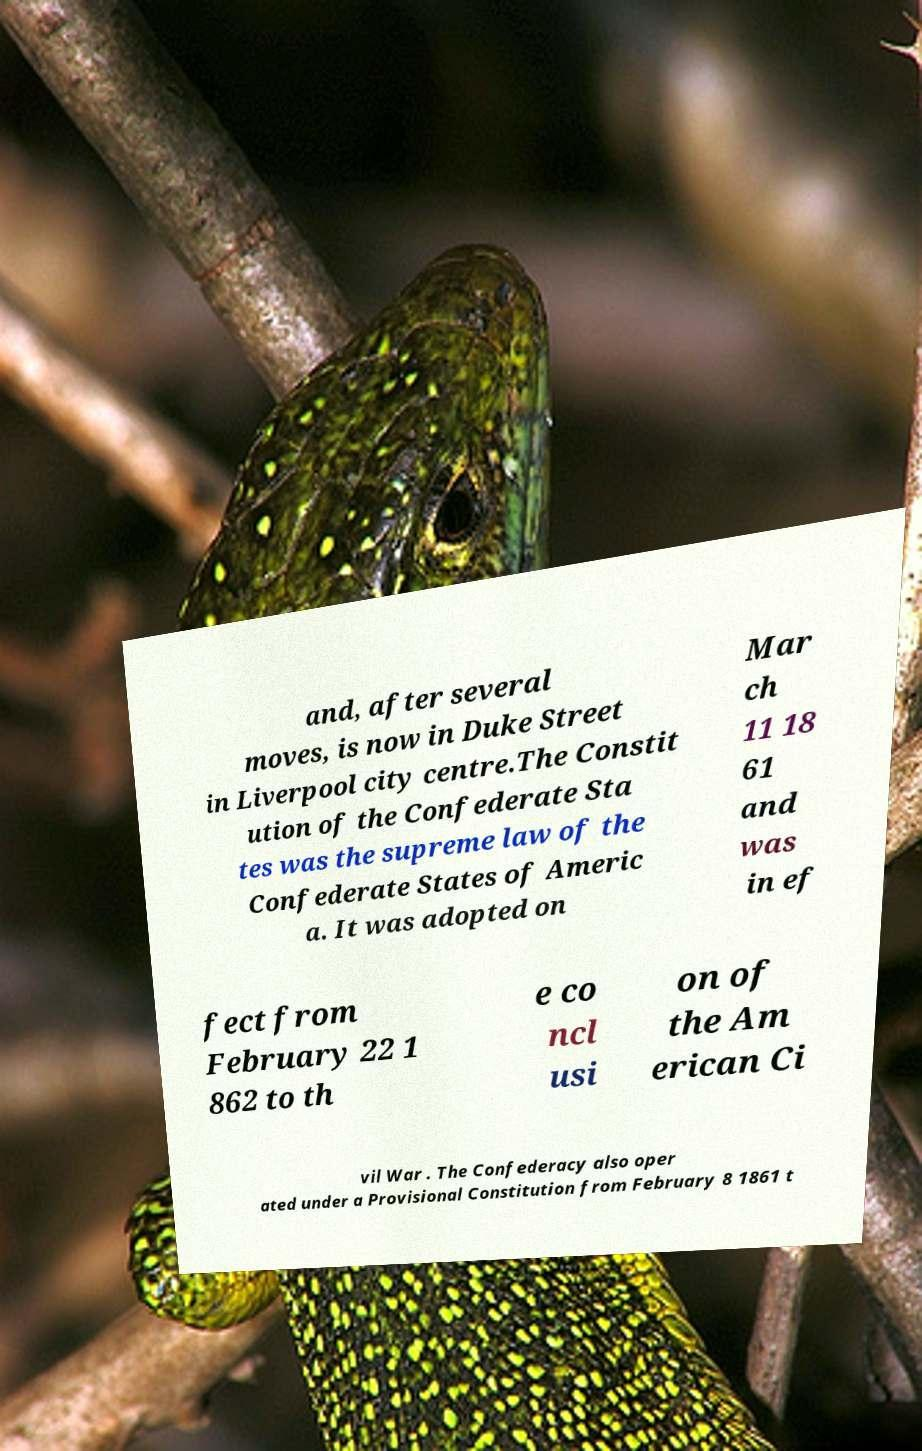For documentation purposes, I need the text within this image transcribed. Could you provide that? and, after several moves, is now in Duke Street in Liverpool city centre.The Constit ution of the Confederate Sta tes was the supreme law of the Confederate States of Americ a. It was adopted on Mar ch 11 18 61 and was in ef fect from February 22 1 862 to th e co ncl usi on of the Am erican Ci vil War . The Confederacy also oper ated under a Provisional Constitution from February 8 1861 t 